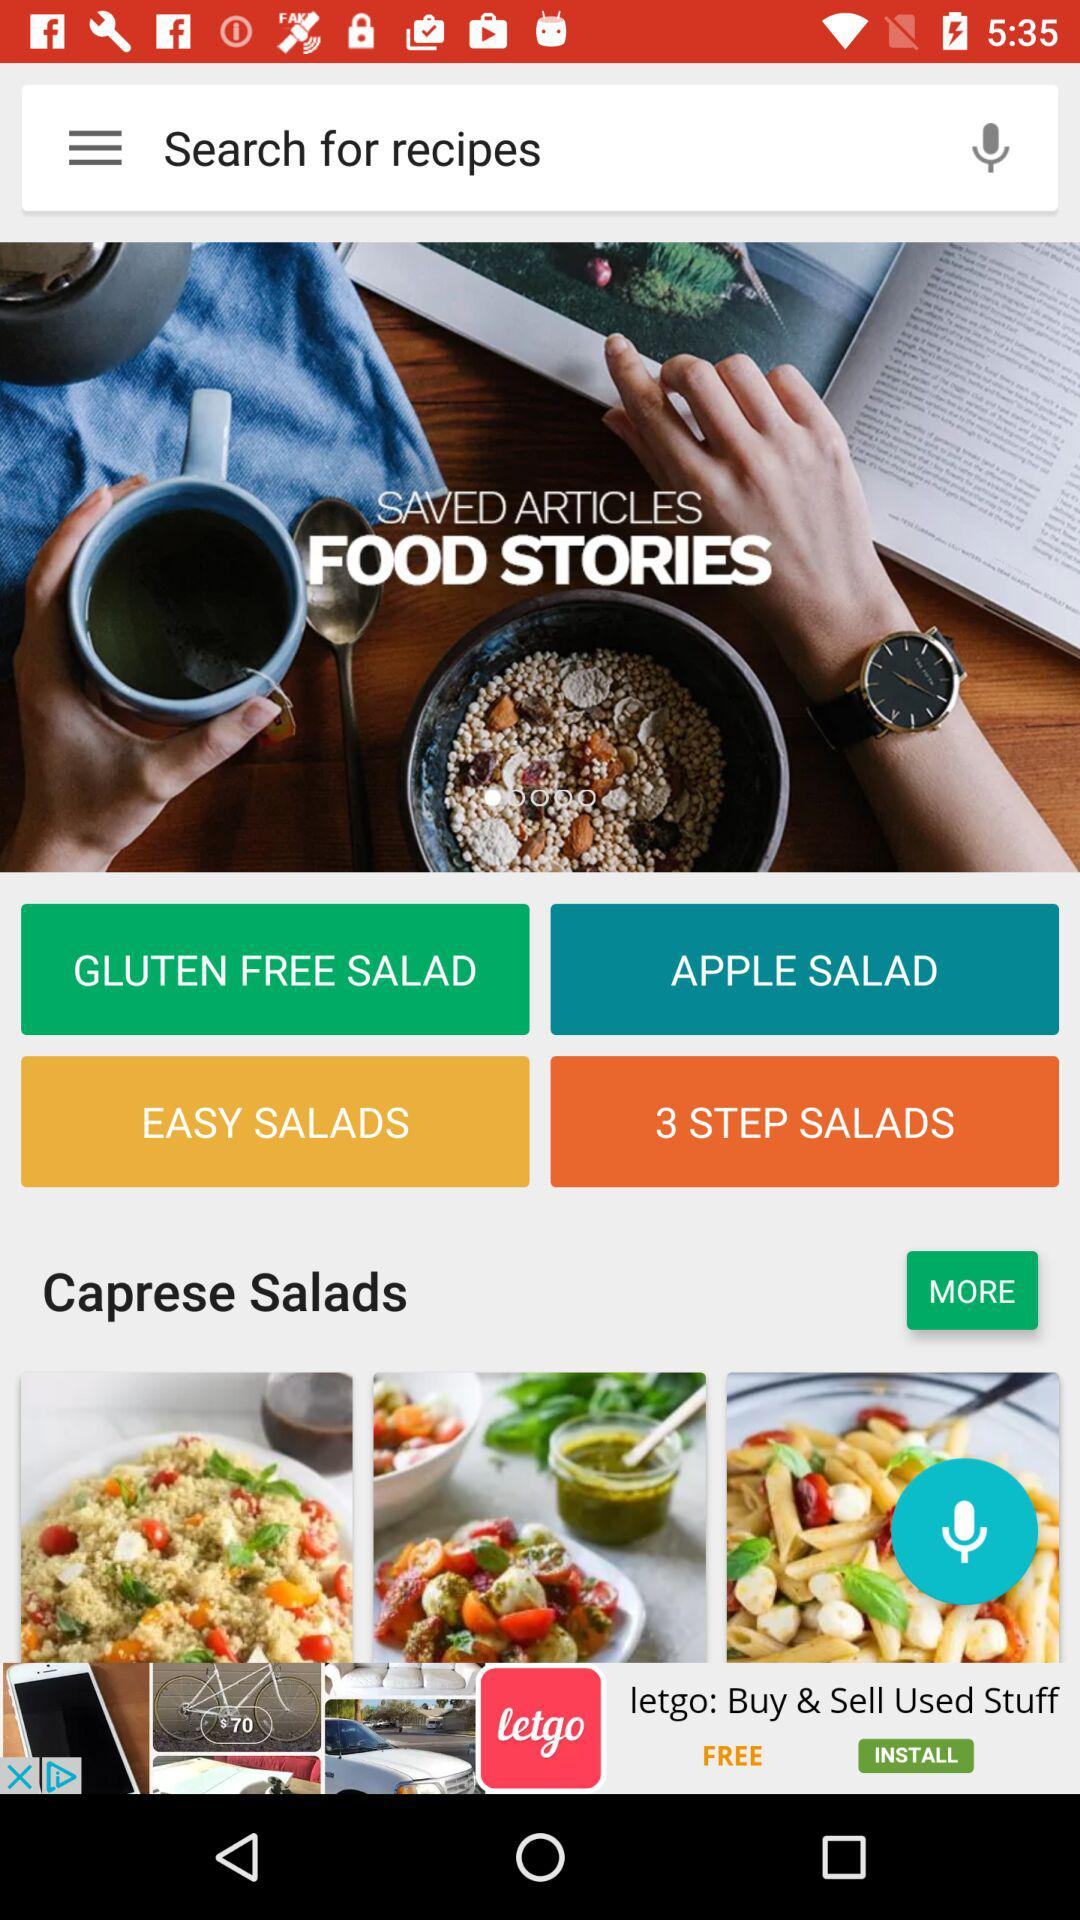What are the different categories of salads? The different categories of salads are "GLUTEN FREE SALAD", "APPLE SALAD", "EASY SALADS" and "3 STEP SALADS". 